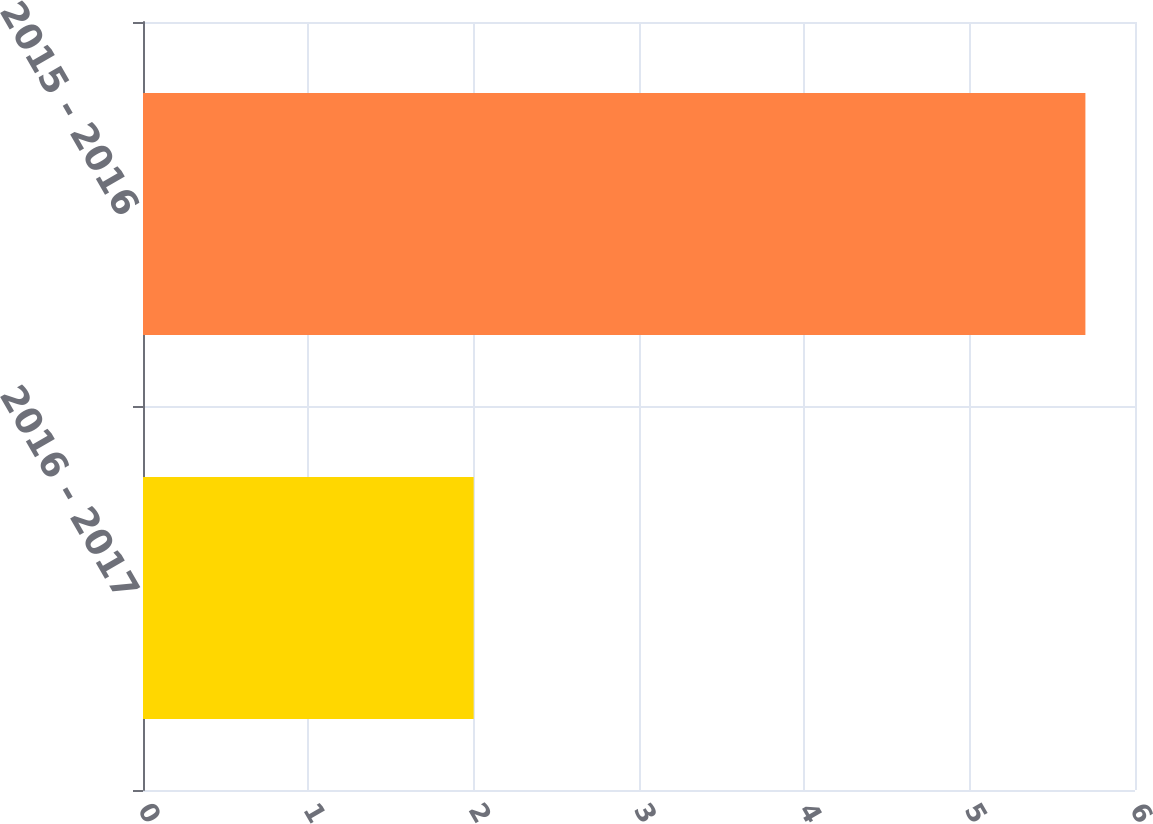Convert chart to OTSL. <chart><loc_0><loc_0><loc_500><loc_500><bar_chart><fcel>2016 - 2017<fcel>2015 - 2016<nl><fcel>2<fcel>5.7<nl></chart> 